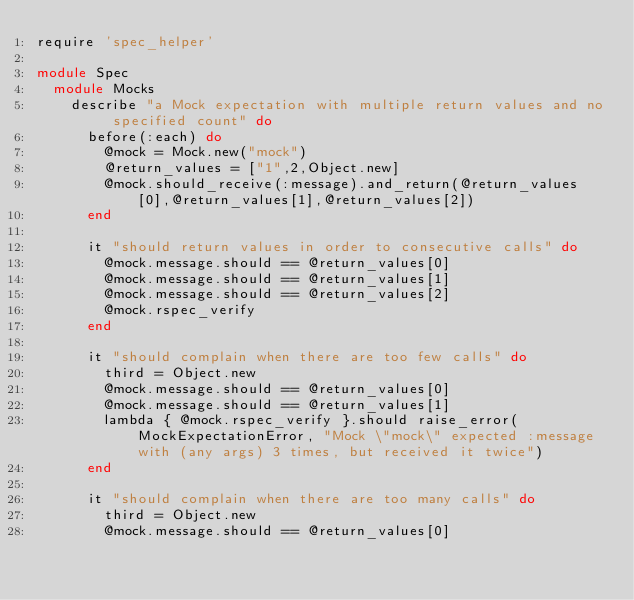<code> <loc_0><loc_0><loc_500><loc_500><_Ruby_>require 'spec_helper'

module Spec
  module Mocks
    describe "a Mock expectation with multiple return values and no specified count" do
      before(:each) do
        @mock = Mock.new("mock")
        @return_values = ["1",2,Object.new]
        @mock.should_receive(:message).and_return(@return_values[0],@return_values[1],@return_values[2])
      end
      
      it "should return values in order to consecutive calls" do
        @mock.message.should == @return_values[0]
        @mock.message.should == @return_values[1]
        @mock.message.should == @return_values[2]
        @mock.rspec_verify
      end

      it "should complain when there are too few calls" do
        third = Object.new
        @mock.message.should == @return_values[0]
        @mock.message.should == @return_values[1]
        lambda { @mock.rspec_verify }.should raise_error(MockExpectationError, "Mock \"mock\" expected :message with (any args) 3 times, but received it twice")
      end

      it "should complain when there are too many calls" do
        third = Object.new
        @mock.message.should == @return_values[0]</code> 